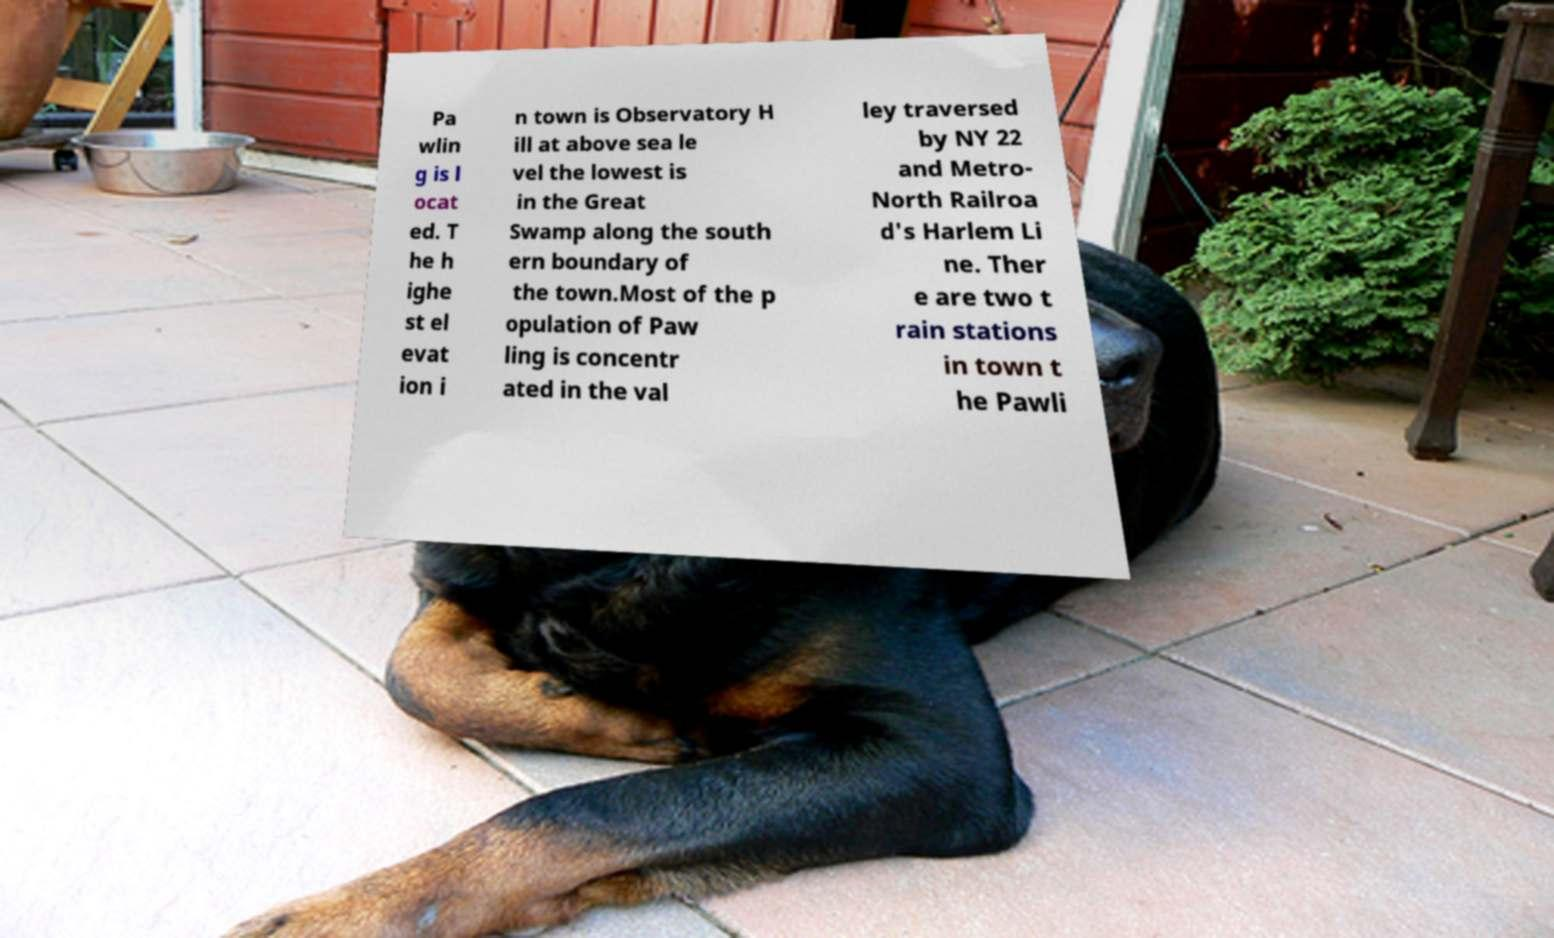Please identify and transcribe the text found in this image. Pa wlin g is l ocat ed. T he h ighe st el evat ion i n town is Observatory H ill at above sea le vel the lowest is in the Great Swamp along the south ern boundary of the town.Most of the p opulation of Paw ling is concentr ated in the val ley traversed by NY 22 and Metro- North Railroa d's Harlem Li ne. Ther e are two t rain stations in town t he Pawli 